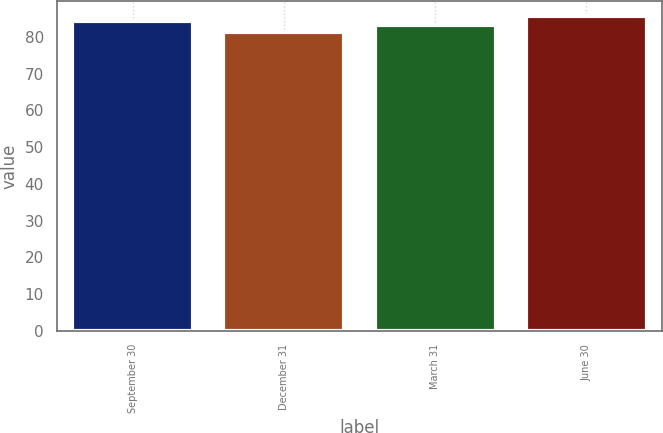Convert chart to OTSL. <chart><loc_0><loc_0><loc_500><loc_500><bar_chart><fcel>September 30<fcel>December 31<fcel>March 31<fcel>June 30<nl><fcel>84.32<fcel>81.18<fcel>83.24<fcel>85.52<nl></chart> 